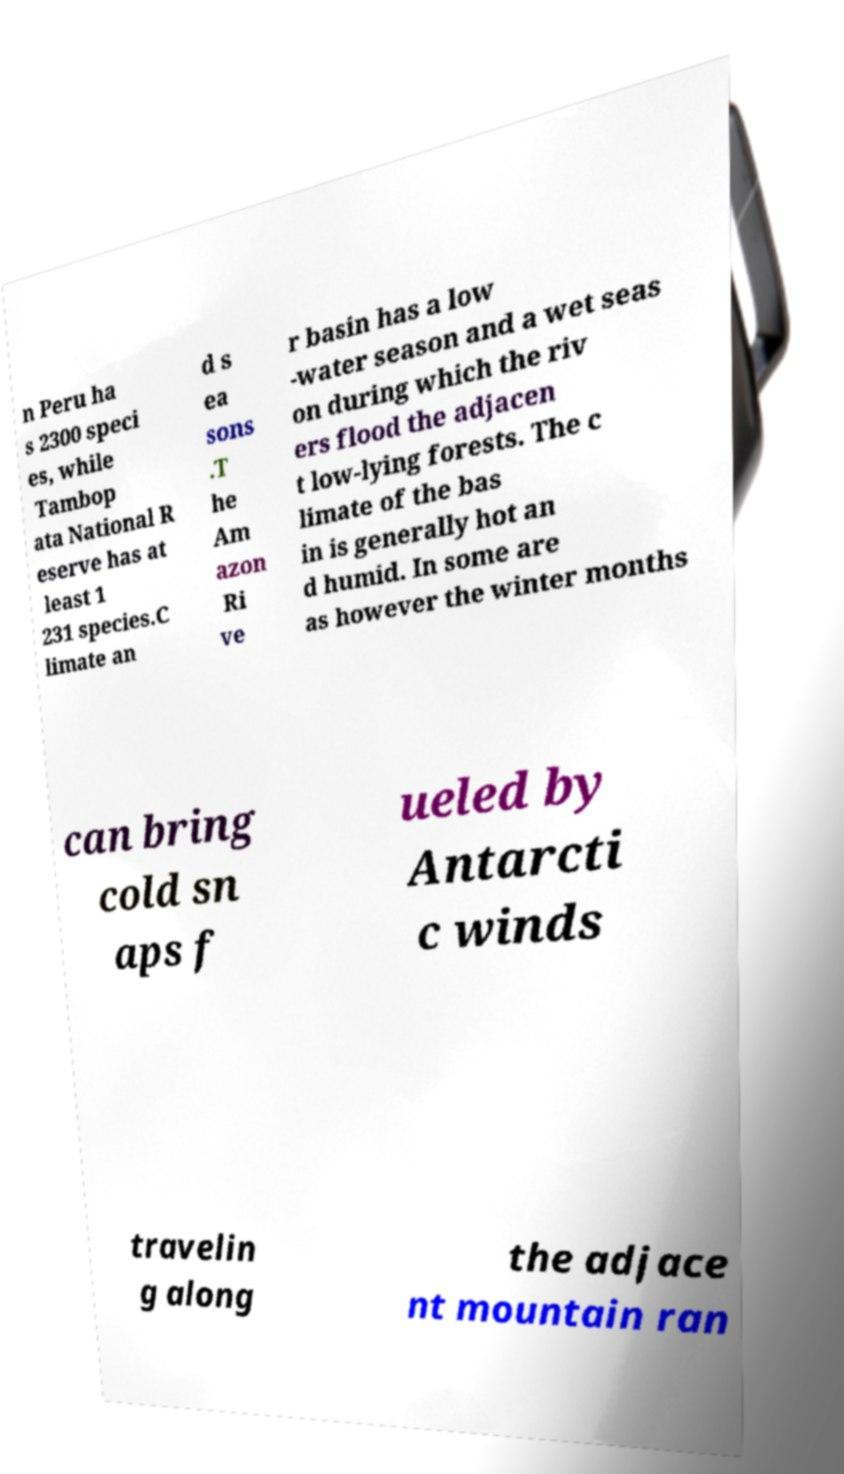Please identify and transcribe the text found in this image. n Peru ha s 2300 speci es, while Tambop ata National R eserve has at least 1 231 species.C limate an d s ea sons .T he Am azon Ri ve r basin has a low -water season and a wet seas on during which the riv ers flood the adjacen t low-lying forests. The c limate of the bas in is generally hot an d humid. In some are as however the winter months can bring cold sn aps f ueled by Antarcti c winds travelin g along the adjace nt mountain ran 